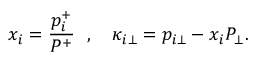Convert formula to latex. <formula><loc_0><loc_0><loc_500><loc_500>x _ { i } = { \frac { p _ { i } ^ { + } } { P ^ { + } } } , \kappa _ { i \bot } = p _ { i \bot } - x _ { i } P _ { \bot } .</formula> 